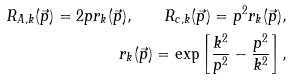<formula> <loc_0><loc_0><loc_500><loc_500>R _ { A , k } ( \vec { p } ) = 2 p r _ { k } ( \vec { p } ) , \quad R _ { c , k } ( \vec { p } ) = p ^ { 2 } r _ { k } ( \vec { p } ) , \\ r _ { k } ( \vec { p } ) = \exp \left [ \frac { k ^ { 2 } } { p ^ { 2 } } - \frac { p ^ { 2 } } { k ^ { 2 } } \right ] ,</formula> 